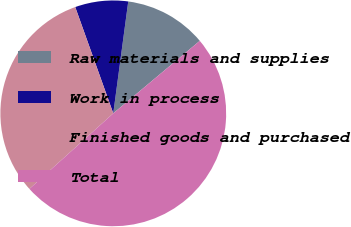Convert chart to OTSL. <chart><loc_0><loc_0><loc_500><loc_500><pie_chart><fcel>Raw materials and supplies<fcel>Work in process<fcel>Finished goods and purchased<fcel>Total<nl><fcel>11.78%<fcel>7.59%<fcel>31.2%<fcel>49.43%<nl></chart> 